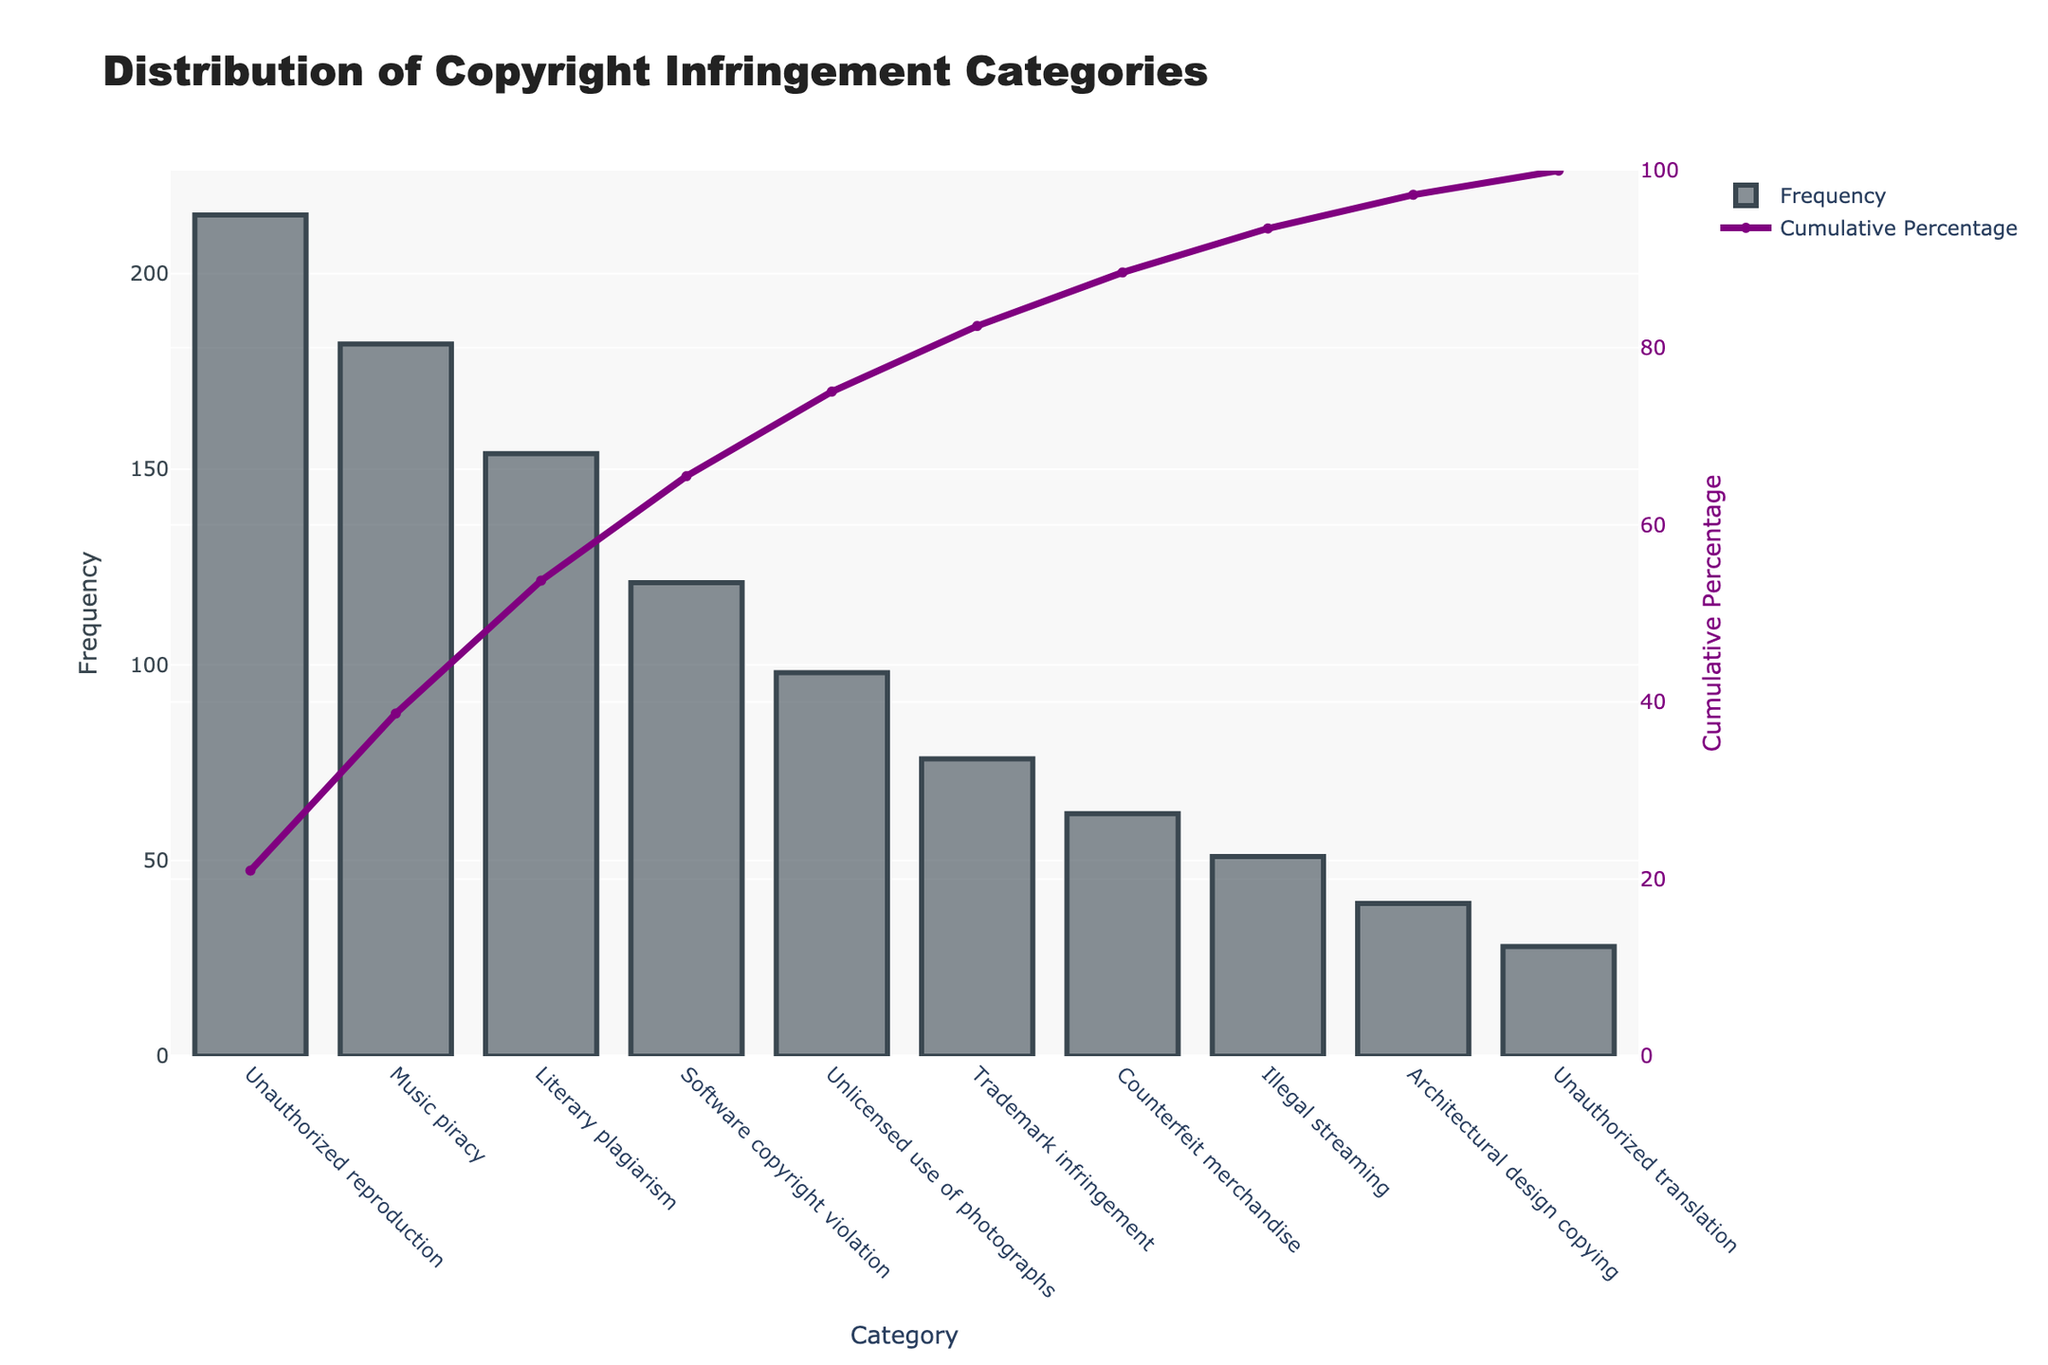What's the most common category of copyright infringement? The most common category is the one with the highest bar. By referring to the height of the bars in descending order, 'Unauthorized reproduction' is the highest.
Answer: Unauthorized reproduction What percentage of cases are covered by the top three categories? Sum the frequencies of the top three categories: Unauthorized reproduction (215), Music piracy (182), Literary plagiarism (154). The total is 215 + 182 + 154 = 551. Calculate the cumulative percentage shown on the line graph at the third category. It's around 56%.
Answer: ~56% Which category has the lowest frequency? The shortest bar represents the category with the lowest frequency. By looking at the bars, 'Unauthorized translation' has the shortest bar.
Answer: Unauthorized translation What is the cumulative percentage up to 'Unlicensed use of photographs'? Find where 'Unlicensed use of photographs' is placed on the x-axis. The cumulative percentage shown on the line graph above this category is around 74%.
Answer: ~74% How many cases of 'Software copyright violation' are there? Identify the bar corresponding to 'Software copyright violation' and read its height, which shows a frequency of 121.
Answer: 121 What fraction of the total cases does 'Illegal streaming' represent? First, find the total number of cases by summing all frequencies: 215 + 182 + 154 + 121 + 98 + 76 + 62 + 51 + 39 + 28 = 1026. The frequency of 'Illegal streaming' is 51. The fraction is 51 / 1026 = 0.0497, approximately 5%.
Answer: ~5% Which category contributes the highest to the cumulative percentage after the top category? The category that contributes the highest to the cumulative percentage after 'Unauthorized reproduction' is 'Music piracy', as it is the next highest bar and added the most increment in the cumulative percentage.
Answer: Music piracy Among 'Trademark infringement' and 'Counterfeit merchandise', which category has more cases? Comparing the heights of the bars, 'Trademark infringement' (76) is greater than 'Counterfeit merchandise' (62).
Answer: Trademark infringement What's the combined frequency of the bottom three categories? Sum the frequencies of 'Unauthorized translation' (28), 'Architectural design copying' (39), and 'Illegal streaming' (51). The total is 28 + 39 + 51 = 118.
Answer: 118 In which frequency range do most categories fall? Observing the bars, most categories fall in the 50-100 range ('Unlicensed use of photographs': 98, 'Trademark infringement': 76, 'Counterfeit merchandise': 62, 'Illegal streaming': 51).
Answer: 50-100 